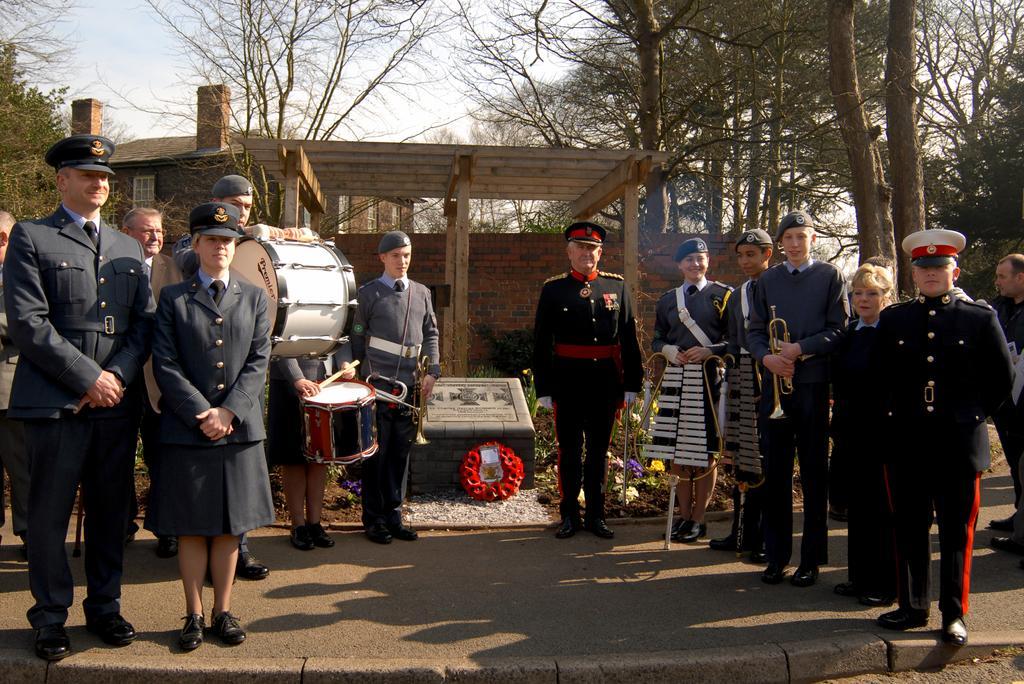In one or two sentences, can you explain what this image depicts? In this picture there are people standing, among them few people holding musical instruments and we can see memorial stone, flowers and plants. In the background of the image we can see shed, building, trees and sky. 